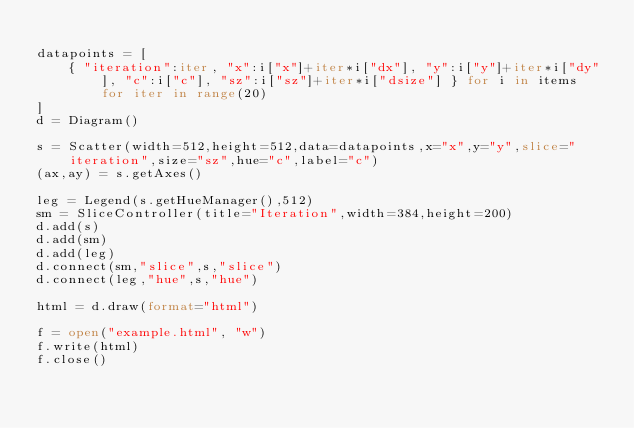Convert code to text. <code><loc_0><loc_0><loc_500><loc_500><_Python_>
datapoints = [
    { "iteration":iter, "x":i["x"]+iter*i["dx"], "y":i["y"]+iter*i["dy"], "c":i["c"], "sz":i["sz"]+iter*i["dsize"] } for i in items for iter in range(20)
]
d = Diagram()

s = Scatter(width=512,height=512,data=datapoints,x="x",y="y",slice="iteration",size="sz",hue="c",label="c")
(ax,ay) = s.getAxes()

leg = Legend(s.getHueManager(),512)
sm = SliceController(title="Iteration",width=384,height=200)
d.add(s)
d.add(sm)
d.add(leg)
d.connect(sm,"slice",s,"slice")
d.connect(leg,"hue",s,"hue")

html = d.draw(format="html")

f = open("example.html", "w")
f.write(html)
f.close()</code> 